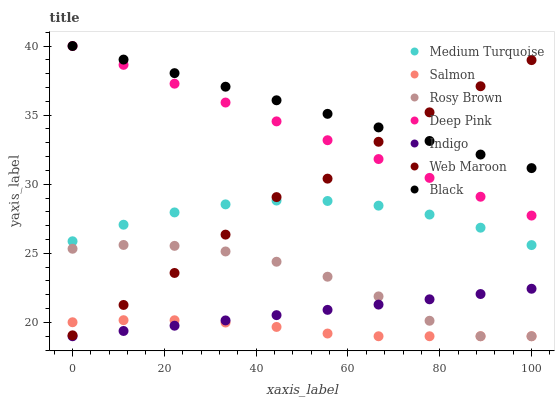Does Salmon have the minimum area under the curve?
Answer yes or no. Yes. Does Black have the maximum area under the curve?
Answer yes or no. Yes. Does Indigo have the minimum area under the curve?
Answer yes or no. No. Does Indigo have the maximum area under the curve?
Answer yes or no. No. Is Indigo the smoothest?
Answer yes or no. Yes. Is Web Maroon the roughest?
Answer yes or no. Yes. Is Salmon the smoothest?
Answer yes or no. No. Is Salmon the roughest?
Answer yes or no. No. Does Indigo have the lowest value?
Answer yes or no. Yes. Does Web Maroon have the lowest value?
Answer yes or no. No. Does Black have the highest value?
Answer yes or no. Yes. Does Indigo have the highest value?
Answer yes or no. No. Is Indigo less than Black?
Answer yes or no. Yes. Is Black greater than Salmon?
Answer yes or no. Yes. Does Salmon intersect Web Maroon?
Answer yes or no. Yes. Is Salmon less than Web Maroon?
Answer yes or no. No. Is Salmon greater than Web Maroon?
Answer yes or no. No. Does Indigo intersect Black?
Answer yes or no. No. 